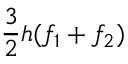<formula> <loc_0><loc_0><loc_500><loc_500>{ \frac { 3 } { 2 } } h ( f _ { 1 } + f _ { 2 } )</formula> 